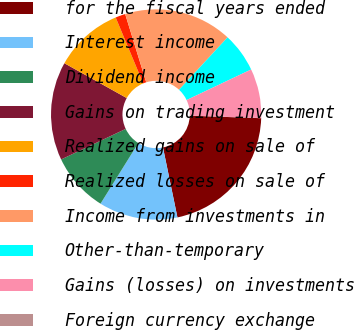Convert chart. <chart><loc_0><loc_0><loc_500><loc_500><pie_chart><fcel>for the fiscal years ended<fcel>Interest income<fcel>Dividend income<fcel>Gains on trading investment<fcel>Realized gains on sale of<fcel>Realized losses on sale of<fcel>Income from investments in<fcel>Other-than-temporary<fcel>Gains (losses) on investments<fcel>Foreign currency exchange<nl><fcel>21.19%<fcel>12.12%<fcel>9.09%<fcel>15.14%<fcel>10.6%<fcel>1.53%<fcel>16.65%<fcel>6.07%<fcel>7.58%<fcel>0.02%<nl></chart> 